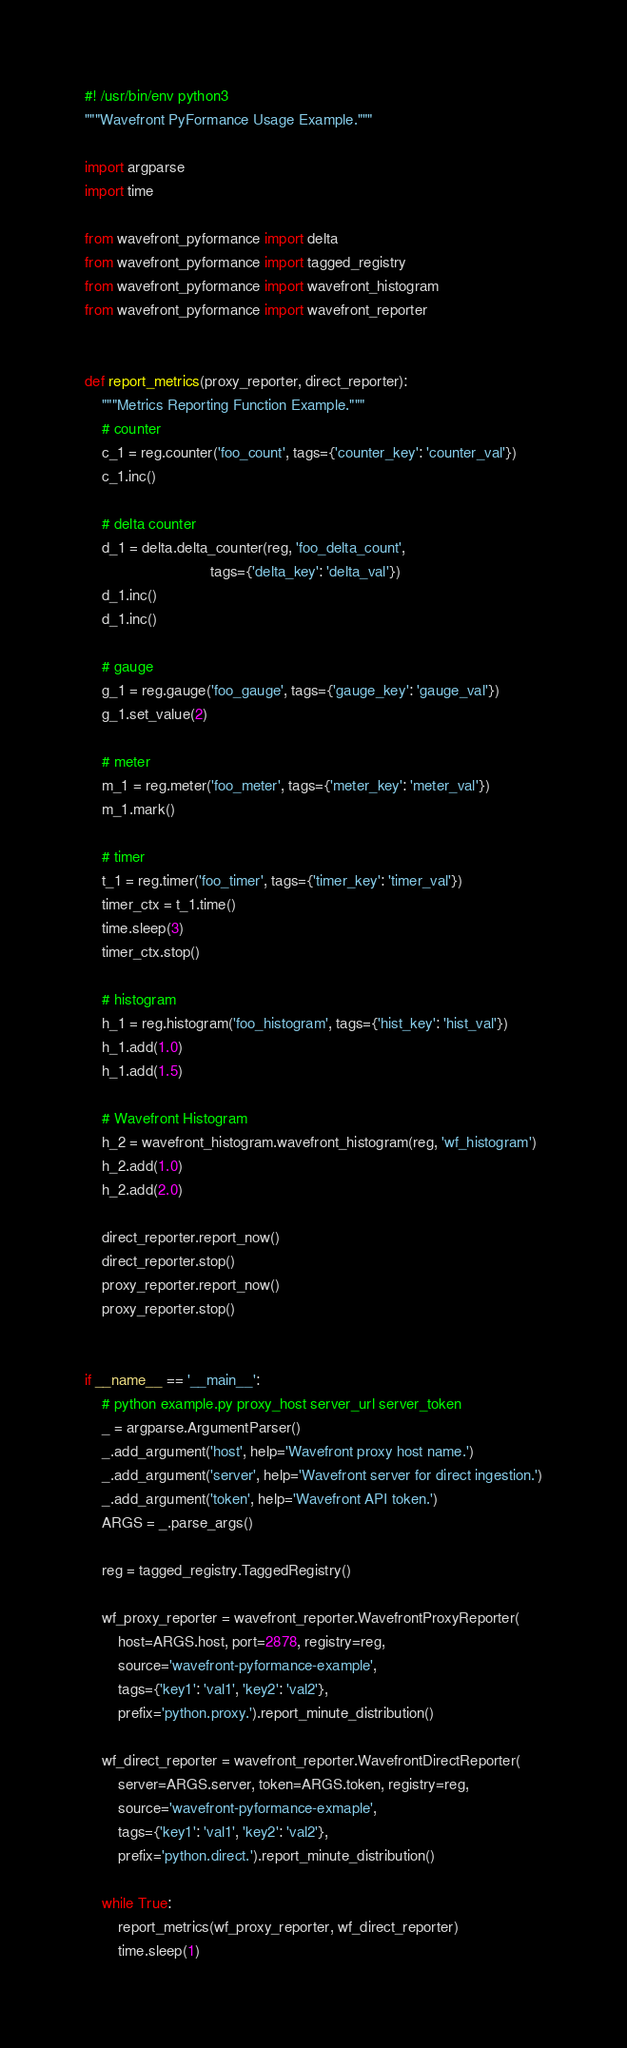<code> <loc_0><loc_0><loc_500><loc_500><_Python_>#! /usr/bin/env python3
"""Wavefront PyFormance Usage Example."""

import argparse
import time

from wavefront_pyformance import delta
from wavefront_pyformance import tagged_registry
from wavefront_pyformance import wavefront_histogram
from wavefront_pyformance import wavefront_reporter


def report_metrics(proxy_reporter, direct_reporter):
    """Metrics Reporting Function Example."""
    # counter
    c_1 = reg.counter('foo_count', tags={'counter_key': 'counter_val'})
    c_1.inc()

    # delta counter
    d_1 = delta.delta_counter(reg, 'foo_delta_count',
                              tags={'delta_key': 'delta_val'})
    d_1.inc()
    d_1.inc()

    # gauge
    g_1 = reg.gauge('foo_gauge', tags={'gauge_key': 'gauge_val'})
    g_1.set_value(2)

    # meter
    m_1 = reg.meter('foo_meter', tags={'meter_key': 'meter_val'})
    m_1.mark()

    # timer
    t_1 = reg.timer('foo_timer', tags={'timer_key': 'timer_val'})
    timer_ctx = t_1.time()
    time.sleep(3)
    timer_ctx.stop()

    # histogram
    h_1 = reg.histogram('foo_histogram', tags={'hist_key': 'hist_val'})
    h_1.add(1.0)
    h_1.add(1.5)

    # Wavefront Histogram
    h_2 = wavefront_histogram.wavefront_histogram(reg, 'wf_histogram')
    h_2.add(1.0)
    h_2.add(2.0)

    direct_reporter.report_now()
    direct_reporter.stop()
    proxy_reporter.report_now()
    proxy_reporter.stop()


if __name__ == '__main__':
    # python example.py proxy_host server_url server_token
    _ = argparse.ArgumentParser()
    _.add_argument('host', help='Wavefront proxy host name.')
    _.add_argument('server', help='Wavefront server for direct ingestion.')
    _.add_argument('token', help='Wavefront API token.')
    ARGS = _.parse_args()

    reg = tagged_registry.TaggedRegistry()

    wf_proxy_reporter = wavefront_reporter.WavefrontProxyReporter(
        host=ARGS.host, port=2878, registry=reg,
        source='wavefront-pyformance-example',
        tags={'key1': 'val1', 'key2': 'val2'},
        prefix='python.proxy.').report_minute_distribution()

    wf_direct_reporter = wavefront_reporter.WavefrontDirectReporter(
        server=ARGS.server, token=ARGS.token, registry=reg,
        source='wavefront-pyformance-exmaple',
        tags={'key1': 'val1', 'key2': 'val2'},
        prefix='python.direct.').report_minute_distribution()

    while True:
        report_metrics(wf_proxy_reporter, wf_direct_reporter)
        time.sleep(1)
</code> 